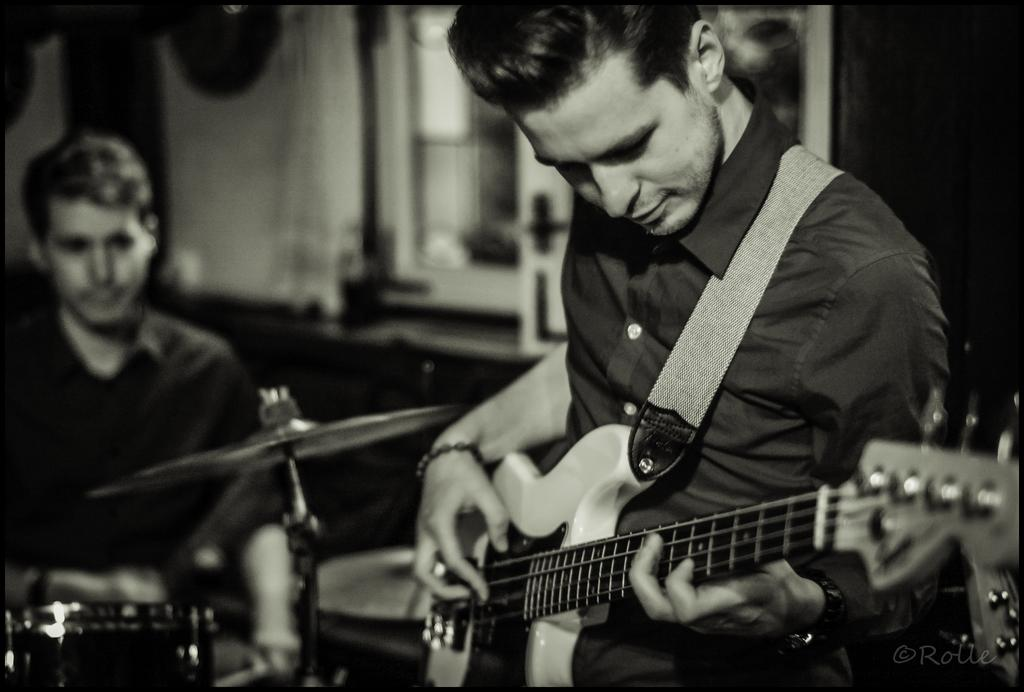How many people are in the image? There are two persons in the image. Can you describe the position of one of the persons? One person is standing on the right side. What is the person on the right side holding? The person on the right side is holding a guitar in their hands. What is the opinion of the milk in the image? There is no milk present in the image, so it is not possible to determine its opinion. 